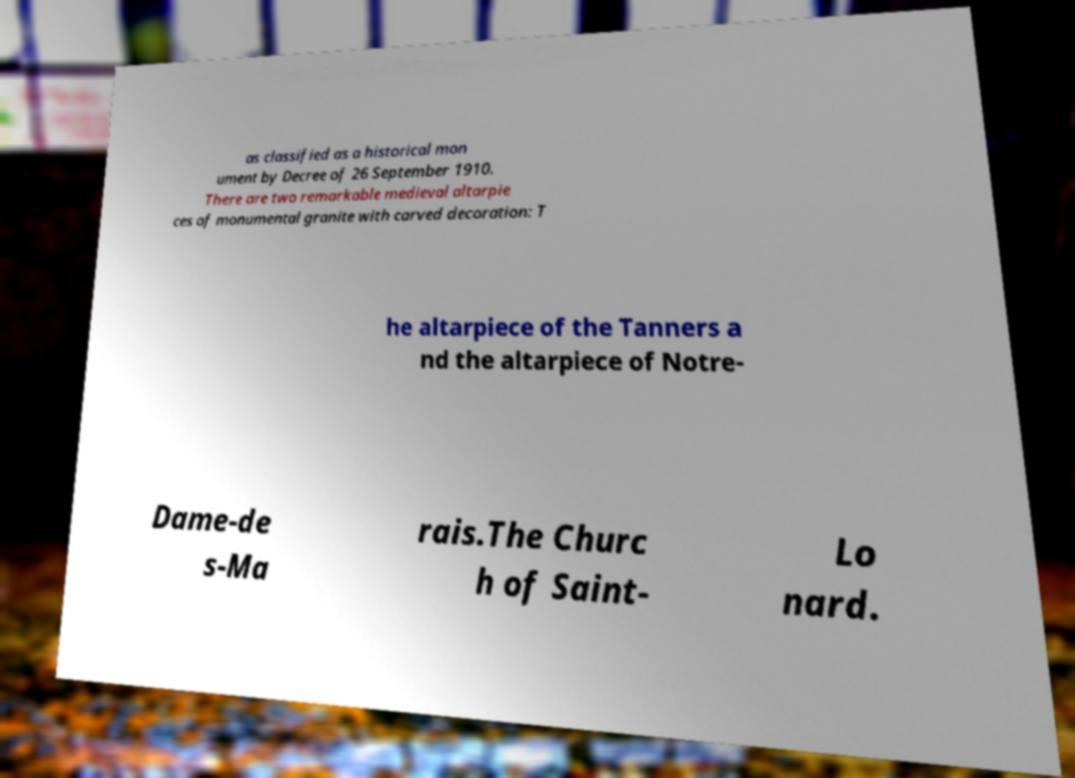Can you read and provide the text displayed in the image?This photo seems to have some interesting text. Can you extract and type it out for me? as classified as a historical mon ument by Decree of 26 September 1910. There are two remarkable medieval altarpie ces of monumental granite with carved decoration: T he altarpiece of the Tanners a nd the altarpiece of Notre- Dame-de s-Ma rais.The Churc h of Saint- Lo nard. 